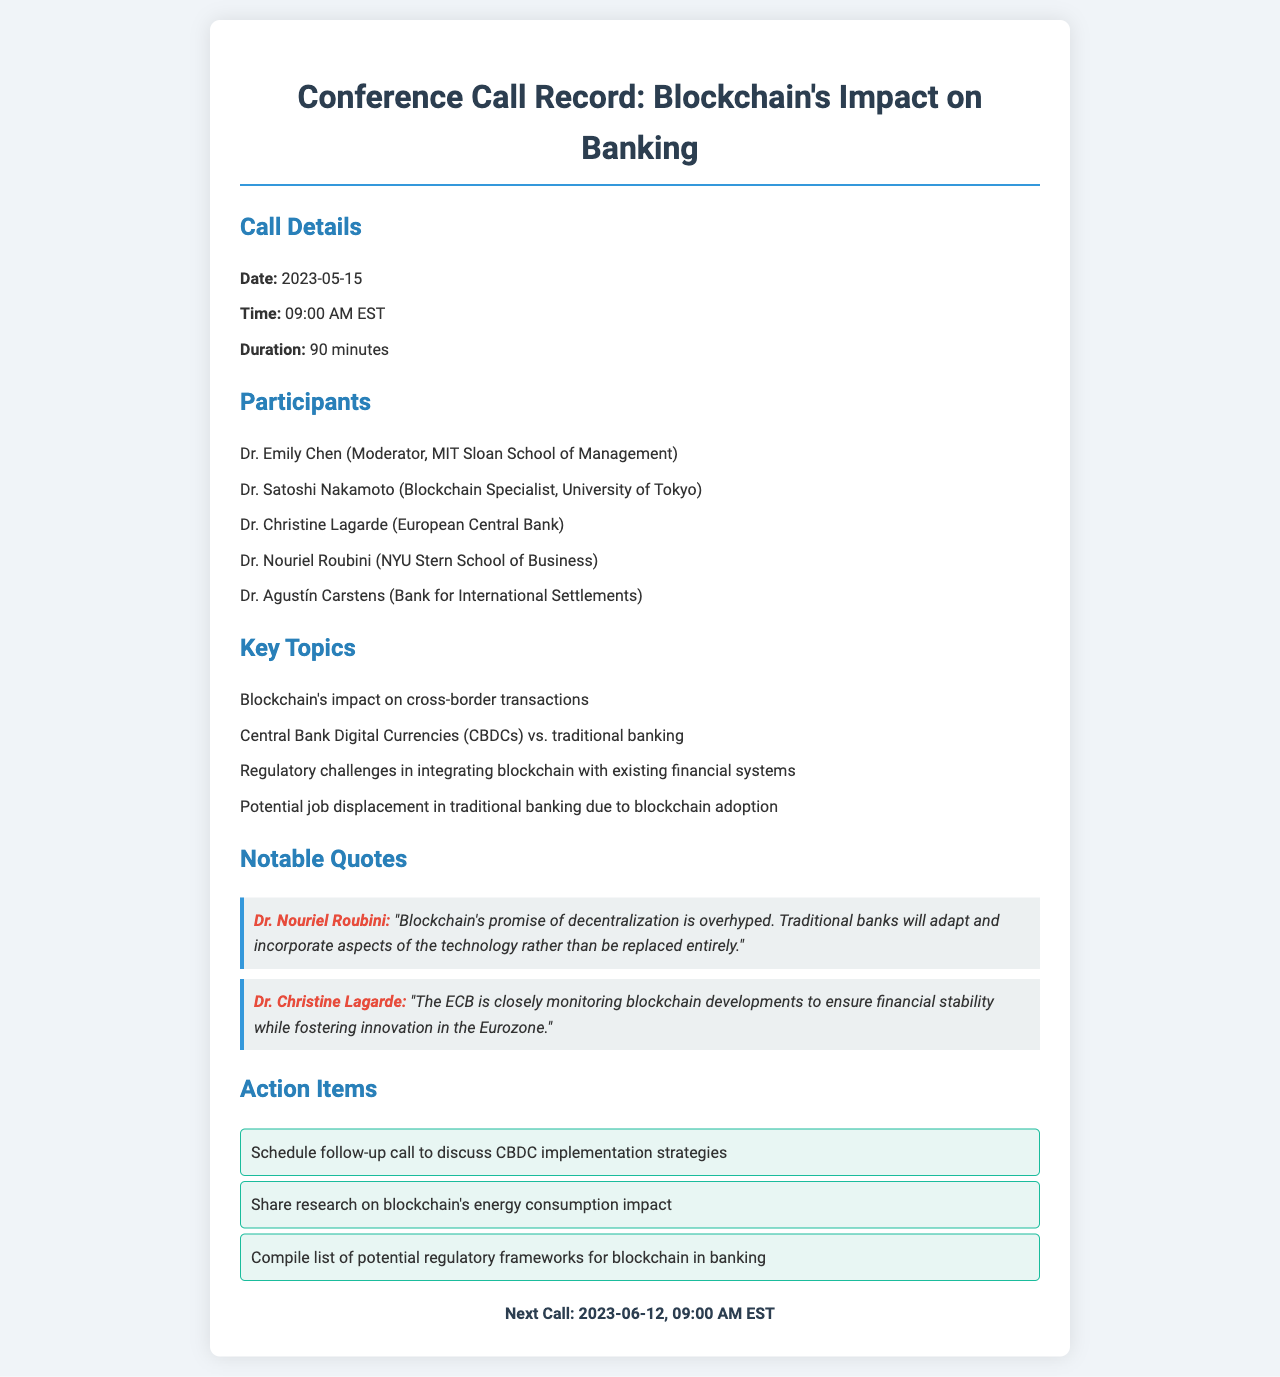What date was the conference call held? The date of the conference call is explicitly mentioned in the call details section of the document.
Answer: 2023-05-15 Who was the moderator of the call? The moderator of the call is listed in the participants section of the document.
Answer: Dr. Emily Chen What were the total number of participants? The number of participants can be determined by counting the names listed in the participants section of the document.
Answer: 5 Which institution does Dr. Christine Lagarde represent? The institution represented by Dr. Christine Lagarde is stated in the participants section of the document.
Answer: European Central Bank What is one of the key topics discussed during the call? The key topics are listed in the key topics section, and one can be selected from that list.
Answer: Central Bank Digital Currencies (CBDCs) vs. traditional banking What is Dr. Nouriel Roubini's stance on blockchain's promise? Dr. Nouriel Roubini's statement regarding blockchain's promise is quoted in the notable quotes section.
Answer: Overhyped How long was the duration of the call? The duration of the call is specified in the call details section of the document.
Answer: 90 minutes What is the date of the next scheduled call? The date of the next scheduled call is provided at the end of the document.
Answer: 2023-06-12 